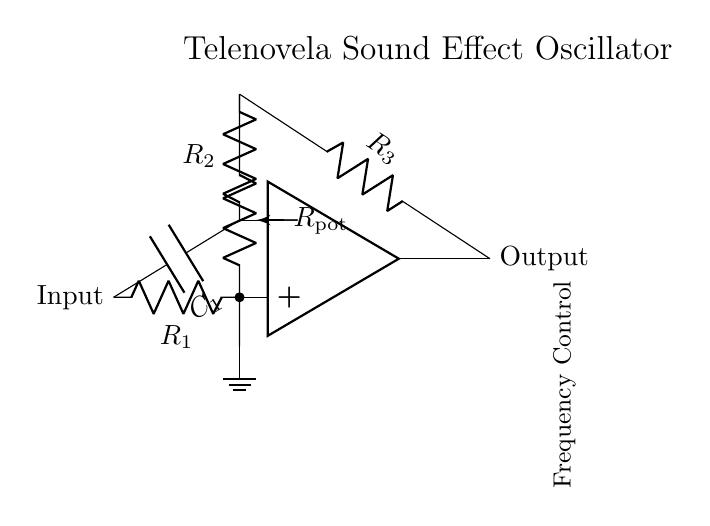What is the type of oscillator in this circuit? The circuit is built around an operational amplifier configured as an oscillator, which is evident by the presence of resistors and capacitors that create feedback for oscillation.
Answer: oscillator How many resistors are present in the circuit? By counting the components, we see there are three resistors labeled R1, R2, and R3 in the circuit, indicating three resistors in total.
Answer: three What role does the potentiometer serve in this circuit? The potentiometer (R_pot) is used to variably adjust resistance, allowing the user to control the frequency of the oscillator by changing the feedback in the circuit.
Answer: frequency control What component is used to store charge in this circuit? The capacitor C1 in the circuit is the component responsible for storing electrical charge, which is essential for the oscillation process.
Answer: capacitor What is connected to the ground in this circuit? The bottom node of the potentiometer (labeled as bottom) is connected to the ground, providing a common reference point for the circuit.
Answer: ground How is the output generated in this circuit? The output is generated from the op-amp's output terminal, where the oscillating signal is taken to produce a sound effect reminiscent of telenovela music.
Answer: from op-amp output 